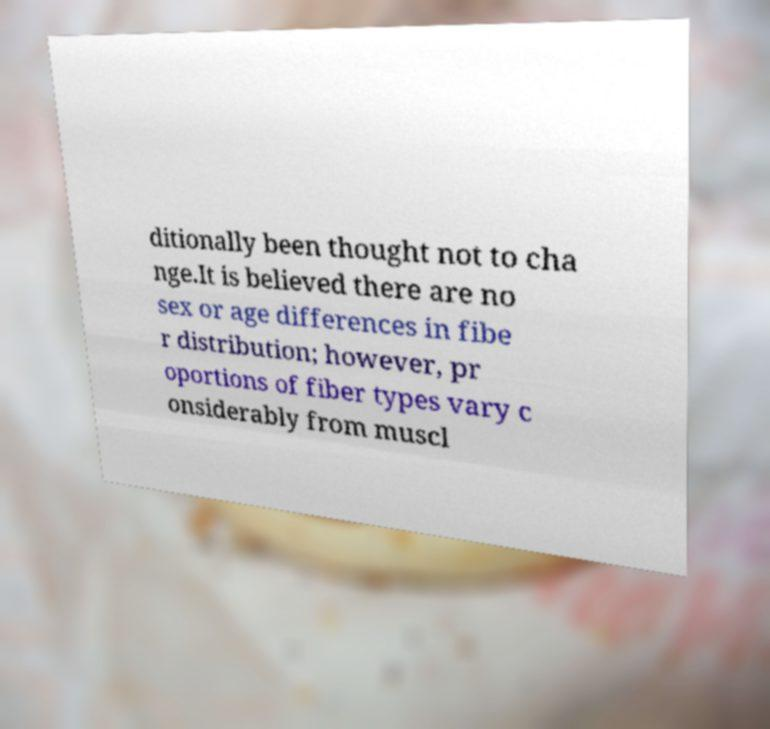Could you extract and type out the text from this image? ditionally been thought not to cha nge.It is believed there are no sex or age differences in fibe r distribution; however, pr oportions of fiber types vary c onsiderably from muscl 